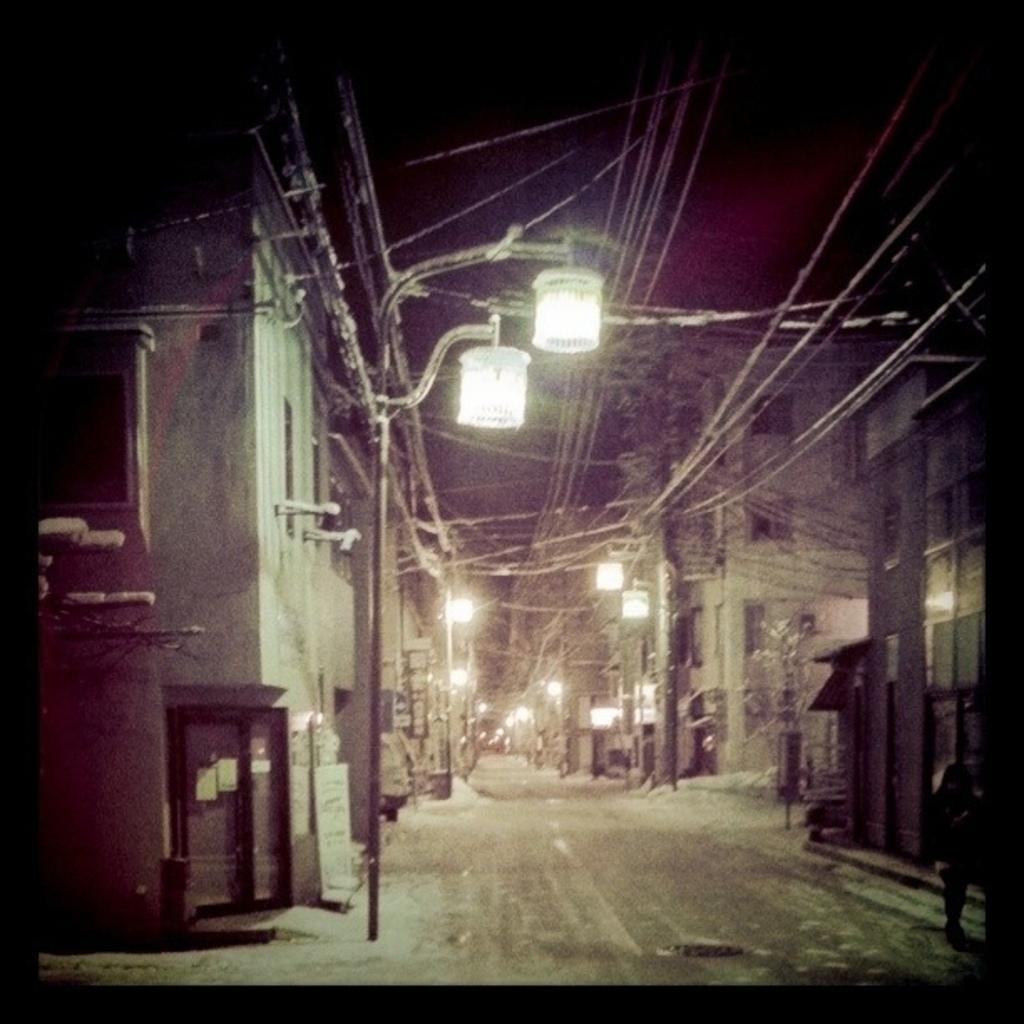What type of structure is present in the image? There is a street light in the image. What else can be seen in the image related to electricity? There are electric poles in the image. What is the main feature of the image? There is a road in the image. What type of structures are on the right side of the image? There are buildings on the right side of the image. Where is the door located in the image? The door is on the left side of the image. How close is the door to the street light? The door is near a street light. What type of cork can be seen in the image? There is no cork present in the image. Can you tell me how many jewels are on the street light? There are no jewels present on the street light in the image. 